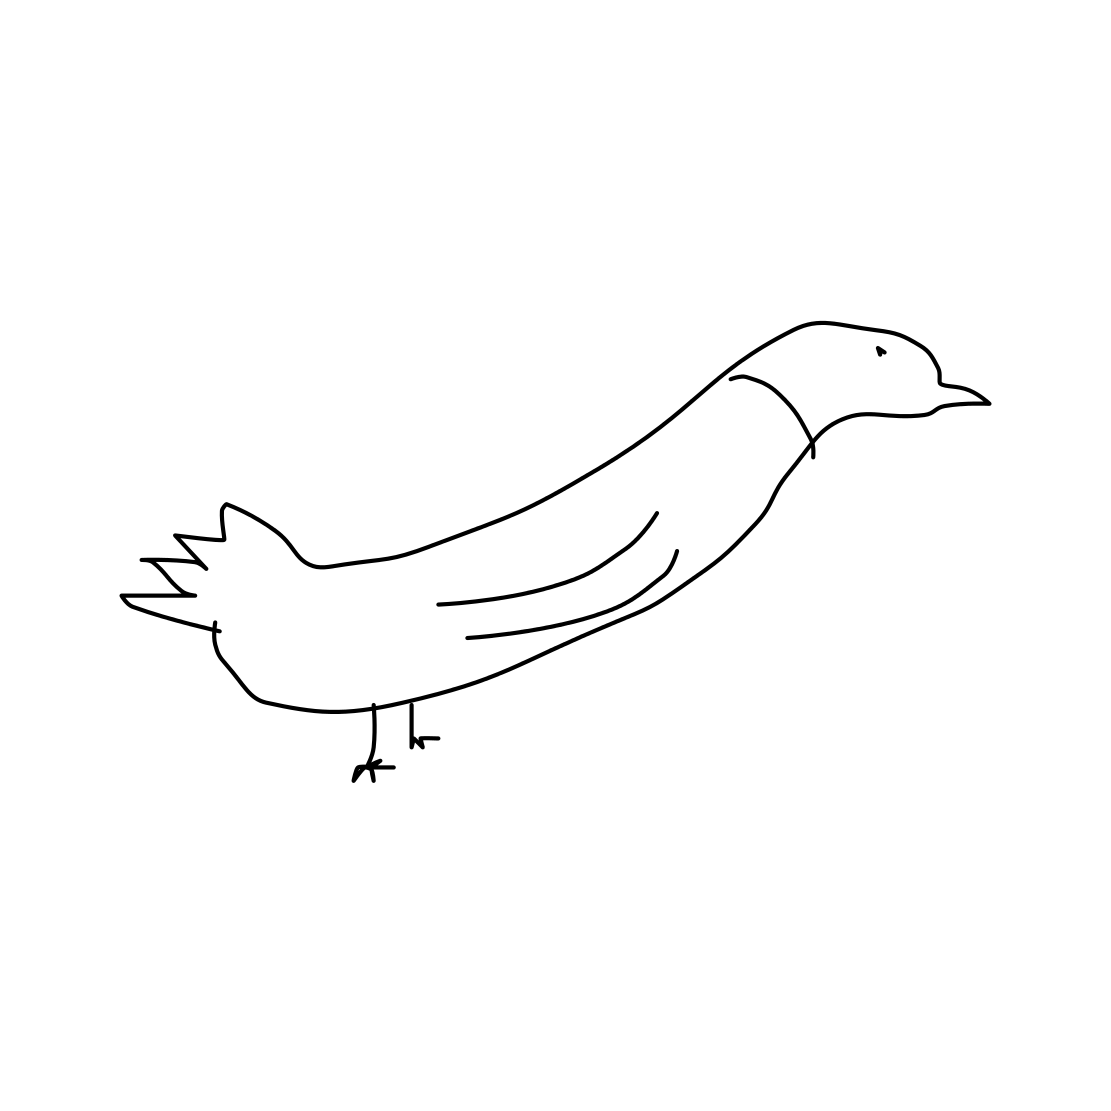Is this a tree in the image? No, the image does not depict a tree. It features a simple line drawing of a bird with a long body and tail, a distinctive head and beak, and standing on two legs. 